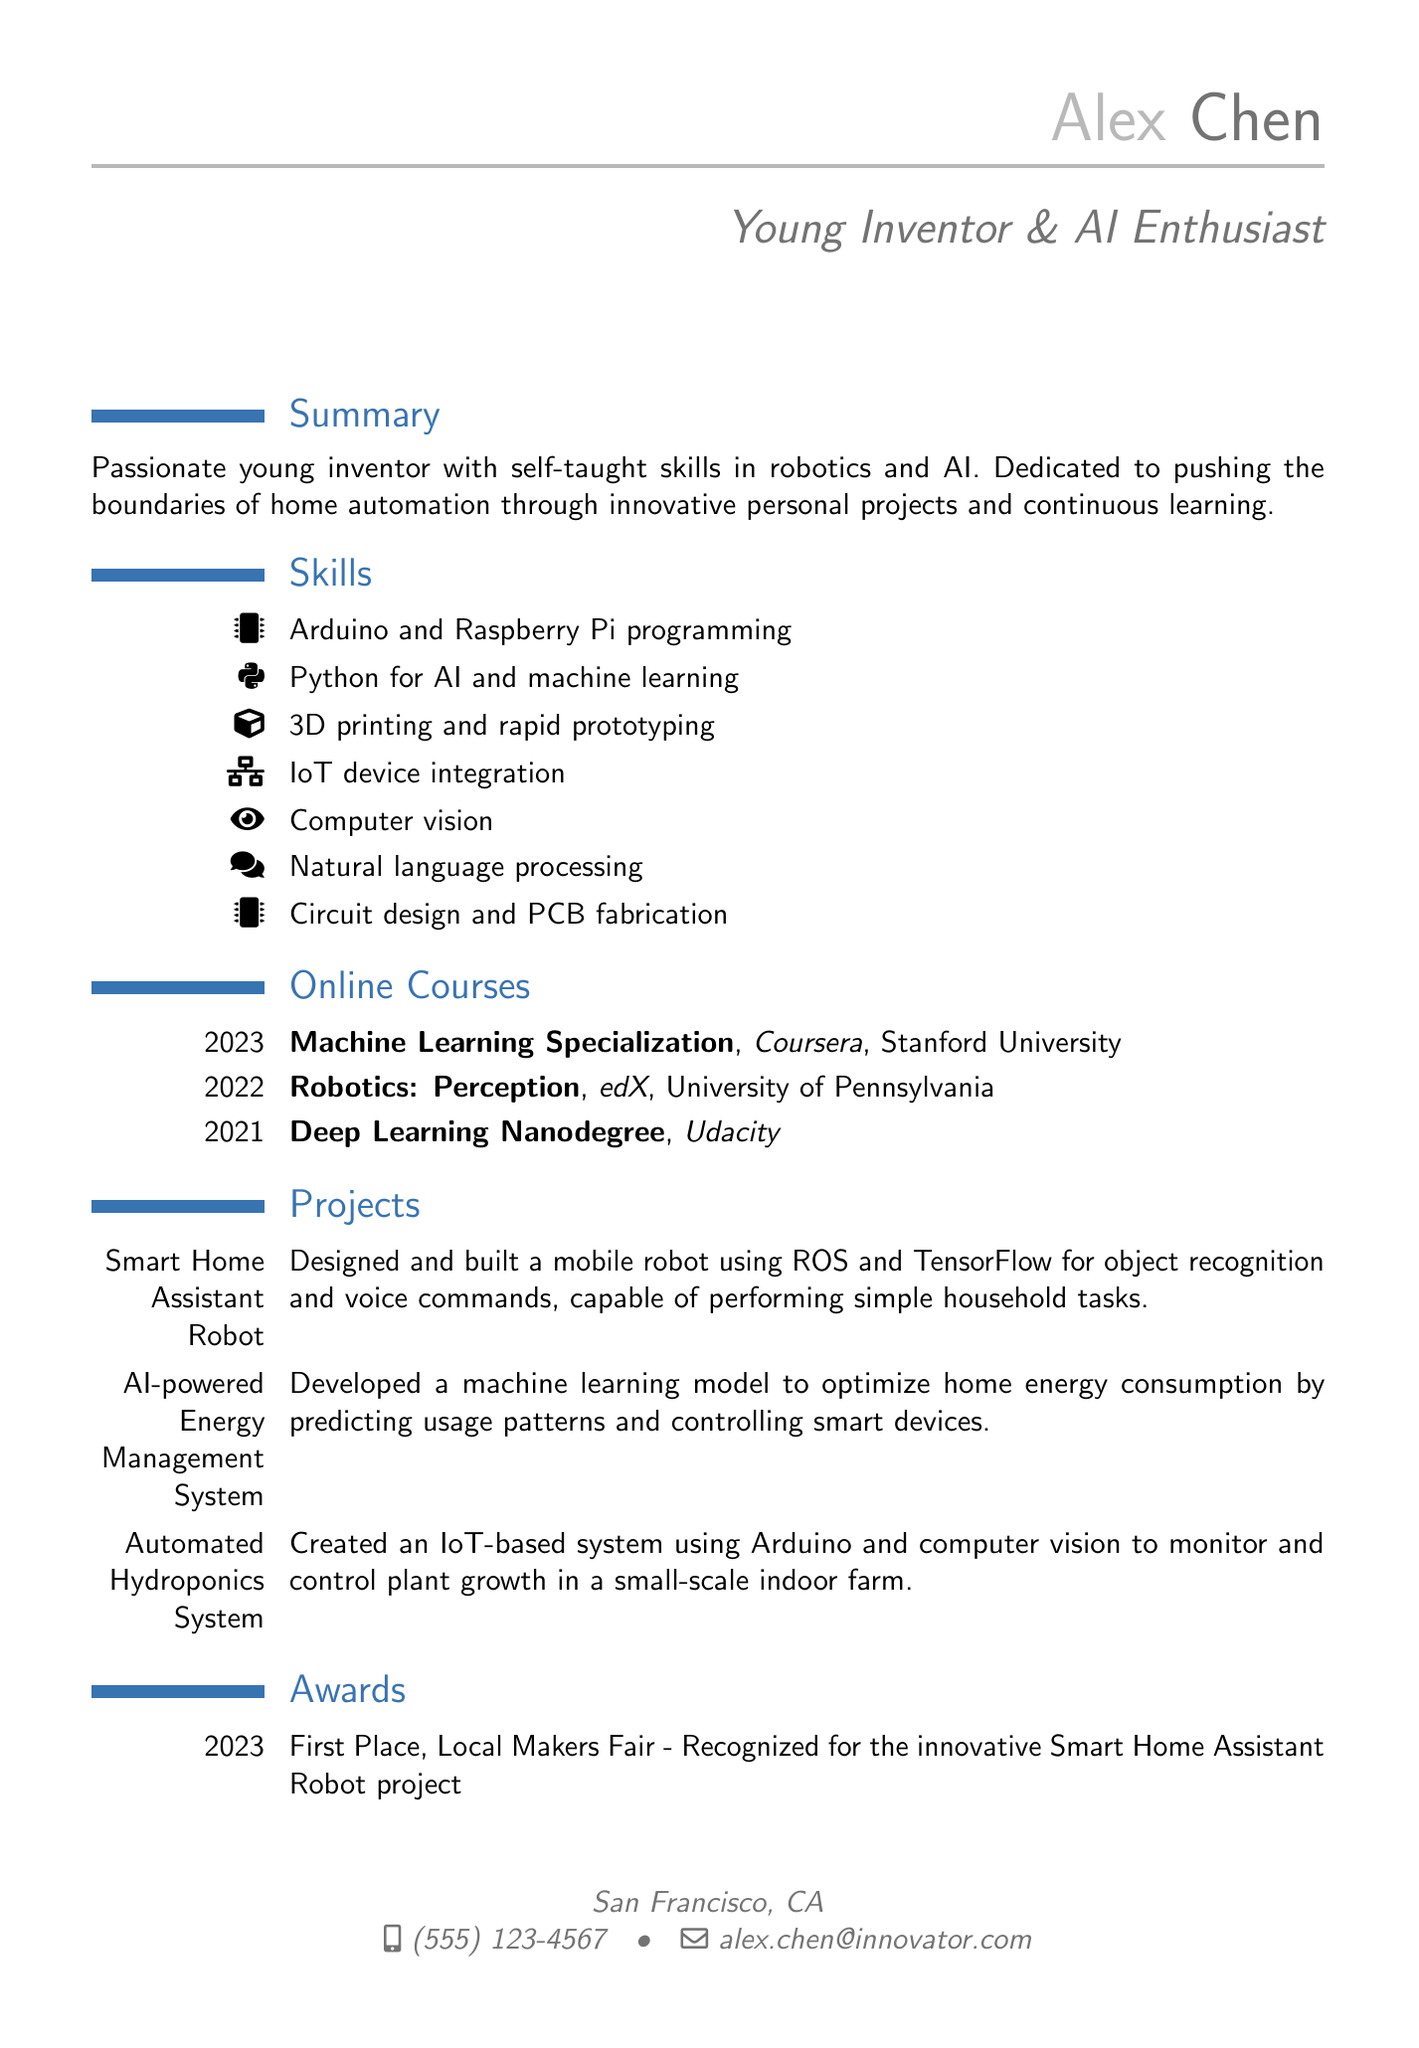What is Alex's email address? The email address is provided in the personal information section of the document.
Answer: alex.chen@innovator.com Which platform offered the "Machine Learning Specialization" course? The platform where the course was offered is listed in the online courses section.
Answer: Coursera What year did Alex complete the "Robotics: Perception" course? The completion date is specified in the online courses section for this particular course.
Answer: 2022 What is the title of the project recognized at the Local Makers Fair? The award section contains the name of the project for which Alex received recognition.
Answer: Smart Home Assistant Robot How many languages can Alex speak? The languages section lists the languages, allowing us to count how many are mentioned.
Answer: 2 What device integration skill does Alex possess? The skills section contains a specific mention of a skill related to device integration.
Answer: IoT device integration What is the primary focus of Alex's projects? The summary provides insight into the general theme of the projects Alex is involved in.
Answer: Home automation What type of system did Alex create using computer vision? The projects section mentions a specific type of system that utilizes computer vision.
Answer: Automated Hydroponics System 